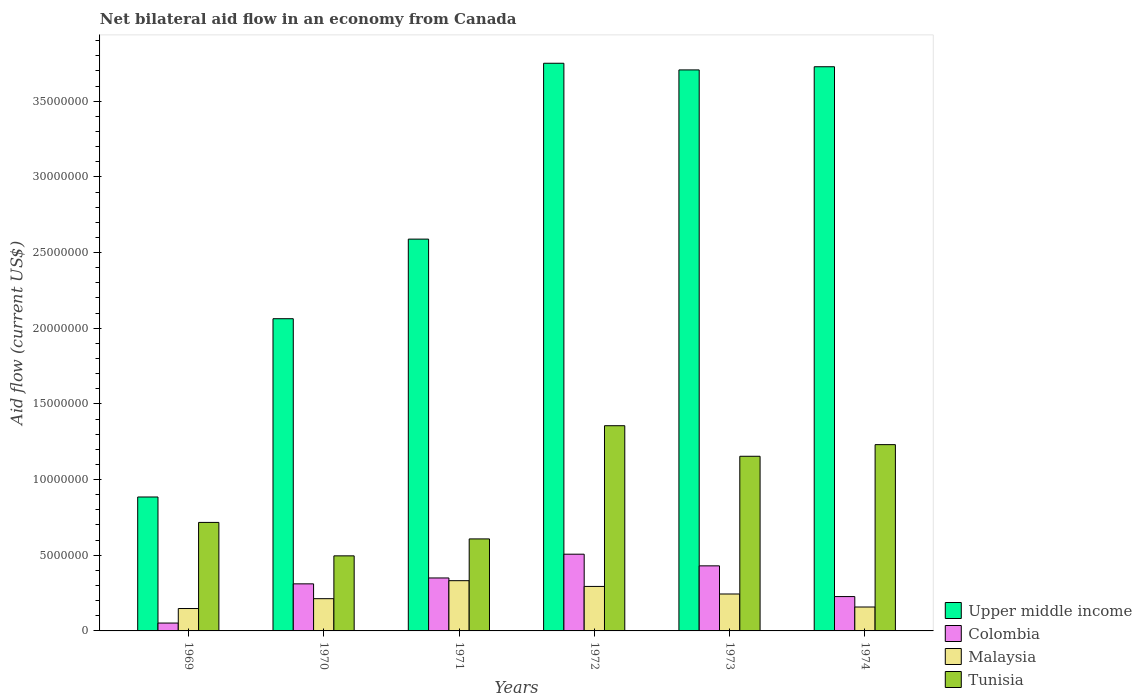Are the number of bars on each tick of the X-axis equal?
Keep it short and to the point. Yes. How many bars are there on the 2nd tick from the left?
Make the answer very short. 4. How many bars are there on the 6th tick from the right?
Keep it short and to the point. 4. What is the label of the 5th group of bars from the left?
Ensure brevity in your answer.  1973. In how many cases, is the number of bars for a given year not equal to the number of legend labels?
Make the answer very short. 0. What is the net bilateral aid flow in Tunisia in 1971?
Your answer should be compact. 6.08e+06. Across all years, what is the maximum net bilateral aid flow in Colombia?
Your answer should be very brief. 5.07e+06. Across all years, what is the minimum net bilateral aid flow in Upper middle income?
Provide a succinct answer. 8.85e+06. In which year was the net bilateral aid flow in Colombia minimum?
Keep it short and to the point. 1969. What is the total net bilateral aid flow in Colombia in the graph?
Give a very brief answer. 1.88e+07. What is the difference between the net bilateral aid flow in Tunisia in 1971 and that in 1972?
Provide a succinct answer. -7.48e+06. What is the difference between the net bilateral aid flow in Upper middle income in 1969 and the net bilateral aid flow in Malaysia in 1971?
Keep it short and to the point. 5.53e+06. What is the average net bilateral aid flow in Malaysia per year?
Make the answer very short. 2.32e+06. In the year 1969, what is the difference between the net bilateral aid flow in Upper middle income and net bilateral aid flow in Colombia?
Offer a terse response. 8.33e+06. What is the ratio of the net bilateral aid flow in Upper middle income in 1969 to that in 1973?
Offer a terse response. 0.24. Is the net bilateral aid flow in Tunisia in 1972 less than that in 1973?
Offer a very short reply. No. Is the difference between the net bilateral aid flow in Upper middle income in 1972 and 1974 greater than the difference between the net bilateral aid flow in Colombia in 1972 and 1974?
Offer a terse response. No. What is the difference between the highest and the lowest net bilateral aid flow in Colombia?
Your answer should be very brief. 4.55e+06. In how many years, is the net bilateral aid flow in Colombia greater than the average net bilateral aid flow in Colombia taken over all years?
Provide a succinct answer. 3. Is the sum of the net bilateral aid flow in Upper middle income in 1973 and 1974 greater than the maximum net bilateral aid flow in Malaysia across all years?
Keep it short and to the point. Yes. Is it the case that in every year, the sum of the net bilateral aid flow in Upper middle income and net bilateral aid flow in Malaysia is greater than the sum of net bilateral aid flow in Tunisia and net bilateral aid flow in Colombia?
Offer a very short reply. Yes. What does the 3rd bar from the left in 1969 represents?
Offer a very short reply. Malaysia. What does the 2nd bar from the right in 1973 represents?
Provide a succinct answer. Malaysia. Is it the case that in every year, the sum of the net bilateral aid flow in Malaysia and net bilateral aid flow in Colombia is greater than the net bilateral aid flow in Tunisia?
Make the answer very short. No. How many bars are there?
Provide a succinct answer. 24. Are all the bars in the graph horizontal?
Keep it short and to the point. No. What is the difference between two consecutive major ticks on the Y-axis?
Provide a short and direct response. 5.00e+06. How are the legend labels stacked?
Ensure brevity in your answer.  Vertical. What is the title of the graph?
Offer a terse response. Net bilateral aid flow in an economy from Canada. Does "Myanmar" appear as one of the legend labels in the graph?
Offer a very short reply. No. What is the Aid flow (current US$) of Upper middle income in 1969?
Ensure brevity in your answer.  8.85e+06. What is the Aid flow (current US$) in Colombia in 1969?
Your answer should be compact. 5.20e+05. What is the Aid flow (current US$) of Malaysia in 1969?
Offer a very short reply. 1.48e+06. What is the Aid flow (current US$) of Tunisia in 1969?
Give a very brief answer. 7.17e+06. What is the Aid flow (current US$) in Upper middle income in 1970?
Provide a succinct answer. 2.06e+07. What is the Aid flow (current US$) of Colombia in 1970?
Offer a very short reply. 3.11e+06. What is the Aid flow (current US$) in Malaysia in 1970?
Provide a short and direct response. 2.13e+06. What is the Aid flow (current US$) in Tunisia in 1970?
Provide a succinct answer. 4.96e+06. What is the Aid flow (current US$) in Upper middle income in 1971?
Provide a short and direct response. 2.59e+07. What is the Aid flow (current US$) in Colombia in 1971?
Offer a terse response. 3.50e+06. What is the Aid flow (current US$) of Malaysia in 1971?
Offer a very short reply. 3.32e+06. What is the Aid flow (current US$) of Tunisia in 1971?
Provide a short and direct response. 6.08e+06. What is the Aid flow (current US$) in Upper middle income in 1972?
Your answer should be very brief. 3.75e+07. What is the Aid flow (current US$) of Colombia in 1972?
Your answer should be very brief. 5.07e+06. What is the Aid flow (current US$) in Malaysia in 1972?
Keep it short and to the point. 2.94e+06. What is the Aid flow (current US$) in Tunisia in 1972?
Offer a terse response. 1.36e+07. What is the Aid flow (current US$) in Upper middle income in 1973?
Give a very brief answer. 3.71e+07. What is the Aid flow (current US$) of Colombia in 1973?
Provide a succinct answer. 4.30e+06. What is the Aid flow (current US$) of Malaysia in 1973?
Offer a very short reply. 2.44e+06. What is the Aid flow (current US$) in Tunisia in 1973?
Provide a short and direct response. 1.15e+07. What is the Aid flow (current US$) of Upper middle income in 1974?
Your answer should be very brief. 3.73e+07. What is the Aid flow (current US$) of Colombia in 1974?
Provide a short and direct response. 2.27e+06. What is the Aid flow (current US$) of Malaysia in 1974?
Provide a short and direct response. 1.58e+06. What is the Aid flow (current US$) of Tunisia in 1974?
Provide a succinct answer. 1.23e+07. Across all years, what is the maximum Aid flow (current US$) in Upper middle income?
Your answer should be very brief. 3.75e+07. Across all years, what is the maximum Aid flow (current US$) in Colombia?
Ensure brevity in your answer.  5.07e+06. Across all years, what is the maximum Aid flow (current US$) in Malaysia?
Give a very brief answer. 3.32e+06. Across all years, what is the maximum Aid flow (current US$) in Tunisia?
Your answer should be compact. 1.36e+07. Across all years, what is the minimum Aid flow (current US$) in Upper middle income?
Your answer should be very brief. 8.85e+06. Across all years, what is the minimum Aid flow (current US$) in Colombia?
Provide a succinct answer. 5.20e+05. Across all years, what is the minimum Aid flow (current US$) of Malaysia?
Make the answer very short. 1.48e+06. Across all years, what is the minimum Aid flow (current US$) in Tunisia?
Ensure brevity in your answer.  4.96e+06. What is the total Aid flow (current US$) of Upper middle income in the graph?
Make the answer very short. 1.67e+08. What is the total Aid flow (current US$) of Colombia in the graph?
Offer a very short reply. 1.88e+07. What is the total Aid flow (current US$) of Malaysia in the graph?
Give a very brief answer. 1.39e+07. What is the total Aid flow (current US$) of Tunisia in the graph?
Your answer should be compact. 5.56e+07. What is the difference between the Aid flow (current US$) of Upper middle income in 1969 and that in 1970?
Keep it short and to the point. -1.18e+07. What is the difference between the Aid flow (current US$) of Colombia in 1969 and that in 1970?
Your answer should be very brief. -2.59e+06. What is the difference between the Aid flow (current US$) in Malaysia in 1969 and that in 1970?
Offer a very short reply. -6.50e+05. What is the difference between the Aid flow (current US$) of Tunisia in 1969 and that in 1970?
Keep it short and to the point. 2.21e+06. What is the difference between the Aid flow (current US$) in Upper middle income in 1969 and that in 1971?
Offer a terse response. -1.70e+07. What is the difference between the Aid flow (current US$) in Colombia in 1969 and that in 1971?
Your response must be concise. -2.98e+06. What is the difference between the Aid flow (current US$) of Malaysia in 1969 and that in 1971?
Your response must be concise. -1.84e+06. What is the difference between the Aid flow (current US$) in Tunisia in 1969 and that in 1971?
Give a very brief answer. 1.09e+06. What is the difference between the Aid flow (current US$) in Upper middle income in 1969 and that in 1972?
Offer a terse response. -2.87e+07. What is the difference between the Aid flow (current US$) of Colombia in 1969 and that in 1972?
Offer a very short reply. -4.55e+06. What is the difference between the Aid flow (current US$) in Malaysia in 1969 and that in 1972?
Provide a succinct answer. -1.46e+06. What is the difference between the Aid flow (current US$) in Tunisia in 1969 and that in 1972?
Ensure brevity in your answer.  -6.39e+06. What is the difference between the Aid flow (current US$) in Upper middle income in 1969 and that in 1973?
Ensure brevity in your answer.  -2.82e+07. What is the difference between the Aid flow (current US$) of Colombia in 1969 and that in 1973?
Keep it short and to the point. -3.78e+06. What is the difference between the Aid flow (current US$) of Malaysia in 1969 and that in 1973?
Your answer should be compact. -9.60e+05. What is the difference between the Aid flow (current US$) of Tunisia in 1969 and that in 1973?
Your response must be concise. -4.37e+06. What is the difference between the Aid flow (current US$) in Upper middle income in 1969 and that in 1974?
Ensure brevity in your answer.  -2.84e+07. What is the difference between the Aid flow (current US$) in Colombia in 1969 and that in 1974?
Make the answer very short. -1.75e+06. What is the difference between the Aid flow (current US$) in Tunisia in 1969 and that in 1974?
Offer a very short reply. -5.14e+06. What is the difference between the Aid flow (current US$) of Upper middle income in 1970 and that in 1971?
Offer a very short reply. -5.26e+06. What is the difference between the Aid flow (current US$) in Colombia in 1970 and that in 1971?
Your answer should be very brief. -3.90e+05. What is the difference between the Aid flow (current US$) of Malaysia in 1970 and that in 1971?
Provide a succinct answer. -1.19e+06. What is the difference between the Aid flow (current US$) in Tunisia in 1970 and that in 1971?
Provide a succinct answer. -1.12e+06. What is the difference between the Aid flow (current US$) in Upper middle income in 1970 and that in 1972?
Provide a succinct answer. -1.69e+07. What is the difference between the Aid flow (current US$) of Colombia in 1970 and that in 1972?
Provide a succinct answer. -1.96e+06. What is the difference between the Aid flow (current US$) of Malaysia in 1970 and that in 1972?
Your answer should be very brief. -8.10e+05. What is the difference between the Aid flow (current US$) of Tunisia in 1970 and that in 1972?
Offer a terse response. -8.60e+06. What is the difference between the Aid flow (current US$) of Upper middle income in 1970 and that in 1973?
Keep it short and to the point. -1.64e+07. What is the difference between the Aid flow (current US$) of Colombia in 1970 and that in 1973?
Offer a very short reply. -1.19e+06. What is the difference between the Aid flow (current US$) in Malaysia in 1970 and that in 1973?
Keep it short and to the point. -3.10e+05. What is the difference between the Aid flow (current US$) in Tunisia in 1970 and that in 1973?
Make the answer very short. -6.58e+06. What is the difference between the Aid flow (current US$) in Upper middle income in 1970 and that in 1974?
Your answer should be very brief. -1.66e+07. What is the difference between the Aid flow (current US$) of Colombia in 1970 and that in 1974?
Your answer should be compact. 8.40e+05. What is the difference between the Aid flow (current US$) of Tunisia in 1970 and that in 1974?
Offer a very short reply. -7.35e+06. What is the difference between the Aid flow (current US$) in Upper middle income in 1971 and that in 1972?
Your answer should be compact. -1.16e+07. What is the difference between the Aid flow (current US$) of Colombia in 1971 and that in 1972?
Your answer should be very brief. -1.57e+06. What is the difference between the Aid flow (current US$) of Malaysia in 1971 and that in 1972?
Offer a terse response. 3.80e+05. What is the difference between the Aid flow (current US$) of Tunisia in 1971 and that in 1972?
Ensure brevity in your answer.  -7.48e+06. What is the difference between the Aid flow (current US$) in Upper middle income in 1971 and that in 1973?
Your answer should be compact. -1.12e+07. What is the difference between the Aid flow (current US$) in Colombia in 1971 and that in 1973?
Offer a terse response. -8.00e+05. What is the difference between the Aid flow (current US$) of Malaysia in 1971 and that in 1973?
Offer a very short reply. 8.80e+05. What is the difference between the Aid flow (current US$) in Tunisia in 1971 and that in 1973?
Give a very brief answer. -5.46e+06. What is the difference between the Aid flow (current US$) in Upper middle income in 1971 and that in 1974?
Your answer should be very brief. -1.14e+07. What is the difference between the Aid flow (current US$) in Colombia in 1971 and that in 1974?
Ensure brevity in your answer.  1.23e+06. What is the difference between the Aid flow (current US$) in Malaysia in 1971 and that in 1974?
Your answer should be very brief. 1.74e+06. What is the difference between the Aid flow (current US$) in Tunisia in 1971 and that in 1974?
Your answer should be very brief. -6.23e+06. What is the difference between the Aid flow (current US$) of Colombia in 1972 and that in 1973?
Keep it short and to the point. 7.70e+05. What is the difference between the Aid flow (current US$) in Malaysia in 1972 and that in 1973?
Provide a succinct answer. 5.00e+05. What is the difference between the Aid flow (current US$) in Tunisia in 1972 and that in 1973?
Your answer should be compact. 2.02e+06. What is the difference between the Aid flow (current US$) in Upper middle income in 1972 and that in 1974?
Make the answer very short. 2.30e+05. What is the difference between the Aid flow (current US$) of Colombia in 1972 and that in 1974?
Offer a very short reply. 2.80e+06. What is the difference between the Aid flow (current US$) in Malaysia in 1972 and that in 1974?
Your answer should be very brief. 1.36e+06. What is the difference between the Aid flow (current US$) of Tunisia in 1972 and that in 1974?
Provide a short and direct response. 1.25e+06. What is the difference between the Aid flow (current US$) of Upper middle income in 1973 and that in 1974?
Provide a short and direct response. -2.10e+05. What is the difference between the Aid flow (current US$) of Colombia in 1973 and that in 1974?
Keep it short and to the point. 2.03e+06. What is the difference between the Aid flow (current US$) of Malaysia in 1973 and that in 1974?
Ensure brevity in your answer.  8.60e+05. What is the difference between the Aid flow (current US$) of Tunisia in 1973 and that in 1974?
Ensure brevity in your answer.  -7.70e+05. What is the difference between the Aid flow (current US$) of Upper middle income in 1969 and the Aid flow (current US$) of Colombia in 1970?
Offer a very short reply. 5.74e+06. What is the difference between the Aid flow (current US$) in Upper middle income in 1969 and the Aid flow (current US$) in Malaysia in 1970?
Make the answer very short. 6.72e+06. What is the difference between the Aid flow (current US$) of Upper middle income in 1969 and the Aid flow (current US$) of Tunisia in 1970?
Make the answer very short. 3.89e+06. What is the difference between the Aid flow (current US$) of Colombia in 1969 and the Aid flow (current US$) of Malaysia in 1970?
Your response must be concise. -1.61e+06. What is the difference between the Aid flow (current US$) of Colombia in 1969 and the Aid flow (current US$) of Tunisia in 1970?
Offer a terse response. -4.44e+06. What is the difference between the Aid flow (current US$) in Malaysia in 1969 and the Aid flow (current US$) in Tunisia in 1970?
Offer a very short reply. -3.48e+06. What is the difference between the Aid flow (current US$) in Upper middle income in 1969 and the Aid flow (current US$) in Colombia in 1971?
Make the answer very short. 5.35e+06. What is the difference between the Aid flow (current US$) in Upper middle income in 1969 and the Aid flow (current US$) in Malaysia in 1971?
Keep it short and to the point. 5.53e+06. What is the difference between the Aid flow (current US$) in Upper middle income in 1969 and the Aid flow (current US$) in Tunisia in 1971?
Provide a succinct answer. 2.77e+06. What is the difference between the Aid flow (current US$) in Colombia in 1969 and the Aid flow (current US$) in Malaysia in 1971?
Your answer should be very brief. -2.80e+06. What is the difference between the Aid flow (current US$) in Colombia in 1969 and the Aid flow (current US$) in Tunisia in 1971?
Provide a short and direct response. -5.56e+06. What is the difference between the Aid flow (current US$) in Malaysia in 1969 and the Aid flow (current US$) in Tunisia in 1971?
Provide a succinct answer. -4.60e+06. What is the difference between the Aid flow (current US$) of Upper middle income in 1969 and the Aid flow (current US$) of Colombia in 1972?
Make the answer very short. 3.78e+06. What is the difference between the Aid flow (current US$) in Upper middle income in 1969 and the Aid flow (current US$) in Malaysia in 1972?
Keep it short and to the point. 5.91e+06. What is the difference between the Aid flow (current US$) in Upper middle income in 1969 and the Aid flow (current US$) in Tunisia in 1972?
Make the answer very short. -4.71e+06. What is the difference between the Aid flow (current US$) of Colombia in 1969 and the Aid flow (current US$) of Malaysia in 1972?
Offer a terse response. -2.42e+06. What is the difference between the Aid flow (current US$) in Colombia in 1969 and the Aid flow (current US$) in Tunisia in 1972?
Your response must be concise. -1.30e+07. What is the difference between the Aid flow (current US$) of Malaysia in 1969 and the Aid flow (current US$) of Tunisia in 1972?
Provide a succinct answer. -1.21e+07. What is the difference between the Aid flow (current US$) of Upper middle income in 1969 and the Aid flow (current US$) of Colombia in 1973?
Ensure brevity in your answer.  4.55e+06. What is the difference between the Aid flow (current US$) in Upper middle income in 1969 and the Aid flow (current US$) in Malaysia in 1973?
Offer a very short reply. 6.41e+06. What is the difference between the Aid flow (current US$) of Upper middle income in 1969 and the Aid flow (current US$) of Tunisia in 1973?
Offer a very short reply. -2.69e+06. What is the difference between the Aid flow (current US$) in Colombia in 1969 and the Aid flow (current US$) in Malaysia in 1973?
Offer a terse response. -1.92e+06. What is the difference between the Aid flow (current US$) of Colombia in 1969 and the Aid flow (current US$) of Tunisia in 1973?
Provide a short and direct response. -1.10e+07. What is the difference between the Aid flow (current US$) of Malaysia in 1969 and the Aid flow (current US$) of Tunisia in 1973?
Your answer should be very brief. -1.01e+07. What is the difference between the Aid flow (current US$) in Upper middle income in 1969 and the Aid flow (current US$) in Colombia in 1974?
Your response must be concise. 6.58e+06. What is the difference between the Aid flow (current US$) of Upper middle income in 1969 and the Aid flow (current US$) of Malaysia in 1974?
Your answer should be compact. 7.27e+06. What is the difference between the Aid flow (current US$) of Upper middle income in 1969 and the Aid flow (current US$) of Tunisia in 1974?
Provide a succinct answer. -3.46e+06. What is the difference between the Aid flow (current US$) of Colombia in 1969 and the Aid flow (current US$) of Malaysia in 1974?
Ensure brevity in your answer.  -1.06e+06. What is the difference between the Aid flow (current US$) of Colombia in 1969 and the Aid flow (current US$) of Tunisia in 1974?
Offer a very short reply. -1.18e+07. What is the difference between the Aid flow (current US$) in Malaysia in 1969 and the Aid flow (current US$) in Tunisia in 1974?
Offer a terse response. -1.08e+07. What is the difference between the Aid flow (current US$) in Upper middle income in 1970 and the Aid flow (current US$) in Colombia in 1971?
Ensure brevity in your answer.  1.71e+07. What is the difference between the Aid flow (current US$) in Upper middle income in 1970 and the Aid flow (current US$) in Malaysia in 1971?
Offer a very short reply. 1.73e+07. What is the difference between the Aid flow (current US$) of Upper middle income in 1970 and the Aid flow (current US$) of Tunisia in 1971?
Make the answer very short. 1.46e+07. What is the difference between the Aid flow (current US$) in Colombia in 1970 and the Aid flow (current US$) in Malaysia in 1971?
Your answer should be compact. -2.10e+05. What is the difference between the Aid flow (current US$) of Colombia in 1970 and the Aid flow (current US$) of Tunisia in 1971?
Offer a very short reply. -2.97e+06. What is the difference between the Aid flow (current US$) in Malaysia in 1970 and the Aid flow (current US$) in Tunisia in 1971?
Give a very brief answer. -3.95e+06. What is the difference between the Aid flow (current US$) of Upper middle income in 1970 and the Aid flow (current US$) of Colombia in 1972?
Make the answer very short. 1.56e+07. What is the difference between the Aid flow (current US$) in Upper middle income in 1970 and the Aid flow (current US$) in Malaysia in 1972?
Ensure brevity in your answer.  1.77e+07. What is the difference between the Aid flow (current US$) in Upper middle income in 1970 and the Aid flow (current US$) in Tunisia in 1972?
Offer a terse response. 7.07e+06. What is the difference between the Aid flow (current US$) of Colombia in 1970 and the Aid flow (current US$) of Tunisia in 1972?
Your answer should be compact. -1.04e+07. What is the difference between the Aid flow (current US$) of Malaysia in 1970 and the Aid flow (current US$) of Tunisia in 1972?
Offer a very short reply. -1.14e+07. What is the difference between the Aid flow (current US$) of Upper middle income in 1970 and the Aid flow (current US$) of Colombia in 1973?
Offer a terse response. 1.63e+07. What is the difference between the Aid flow (current US$) of Upper middle income in 1970 and the Aid flow (current US$) of Malaysia in 1973?
Your answer should be very brief. 1.82e+07. What is the difference between the Aid flow (current US$) in Upper middle income in 1970 and the Aid flow (current US$) in Tunisia in 1973?
Your response must be concise. 9.09e+06. What is the difference between the Aid flow (current US$) in Colombia in 1970 and the Aid flow (current US$) in Malaysia in 1973?
Make the answer very short. 6.70e+05. What is the difference between the Aid flow (current US$) in Colombia in 1970 and the Aid flow (current US$) in Tunisia in 1973?
Keep it short and to the point. -8.43e+06. What is the difference between the Aid flow (current US$) in Malaysia in 1970 and the Aid flow (current US$) in Tunisia in 1973?
Give a very brief answer. -9.41e+06. What is the difference between the Aid flow (current US$) in Upper middle income in 1970 and the Aid flow (current US$) in Colombia in 1974?
Give a very brief answer. 1.84e+07. What is the difference between the Aid flow (current US$) of Upper middle income in 1970 and the Aid flow (current US$) of Malaysia in 1974?
Offer a very short reply. 1.90e+07. What is the difference between the Aid flow (current US$) of Upper middle income in 1970 and the Aid flow (current US$) of Tunisia in 1974?
Ensure brevity in your answer.  8.32e+06. What is the difference between the Aid flow (current US$) of Colombia in 1970 and the Aid flow (current US$) of Malaysia in 1974?
Offer a very short reply. 1.53e+06. What is the difference between the Aid flow (current US$) of Colombia in 1970 and the Aid flow (current US$) of Tunisia in 1974?
Your response must be concise. -9.20e+06. What is the difference between the Aid flow (current US$) in Malaysia in 1970 and the Aid flow (current US$) in Tunisia in 1974?
Provide a succinct answer. -1.02e+07. What is the difference between the Aid flow (current US$) in Upper middle income in 1971 and the Aid flow (current US$) in Colombia in 1972?
Ensure brevity in your answer.  2.08e+07. What is the difference between the Aid flow (current US$) in Upper middle income in 1971 and the Aid flow (current US$) in Malaysia in 1972?
Offer a terse response. 2.30e+07. What is the difference between the Aid flow (current US$) of Upper middle income in 1971 and the Aid flow (current US$) of Tunisia in 1972?
Give a very brief answer. 1.23e+07. What is the difference between the Aid flow (current US$) of Colombia in 1971 and the Aid flow (current US$) of Malaysia in 1972?
Provide a short and direct response. 5.60e+05. What is the difference between the Aid flow (current US$) in Colombia in 1971 and the Aid flow (current US$) in Tunisia in 1972?
Ensure brevity in your answer.  -1.01e+07. What is the difference between the Aid flow (current US$) in Malaysia in 1971 and the Aid flow (current US$) in Tunisia in 1972?
Keep it short and to the point. -1.02e+07. What is the difference between the Aid flow (current US$) of Upper middle income in 1971 and the Aid flow (current US$) of Colombia in 1973?
Keep it short and to the point. 2.16e+07. What is the difference between the Aid flow (current US$) of Upper middle income in 1971 and the Aid flow (current US$) of Malaysia in 1973?
Keep it short and to the point. 2.34e+07. What is the difference between the Aid flow (current US$) of Upper middle income in 1971 and the Aid flow (current US$) of Tunisia in 1973?
Give a very brief answer. 1.44e+07. What is the difference between the Aid flow (current US$) in Colombia in 1971 and the Aid flow (current US$) in Malaysia in 1973?
Make the answer very short. 1.06e+06. What is the difference between the Aid flow (current US$) of Colombia in 1971 and the Aid flow (current US$) of Tunisia in 1973?
Keep it short and to the point. -8.04e+06. What is the difference between the Aid flow (current US$) of Malaysia in 1971 and the Aid flow (current US$) of Tunisia in 1973?
Provide a succinct answer. -8.22e+06. What is the difference between the Aid flow (current US$) in Upper middle income in 1971 and the Aid flow (current US$) in Colombia in 1974?
Give a very brief answer. 2.36e+07. What is the difference between the Aid flow (current US$) of Upper middle income in 1971 and the Aid flow (current US$) of Malaysia in 1974?
Offer a terse response. 2.43e+07. What is the difference between the Aid flow (current US$) in Upper middle income in 1971 and the Aid flow (current US$) in Tunisia in 1974?
Offer a terse response. 1.36e+07. What is the difference between the Aid flow (current US$) in Colombia in 1971 and the Aid flow (current US$) in Malaysia in 1974?
Give a very brief answer. 1.92e+06. What is the difference between the Aid flow (current US$) in Colombia in 1971 and the Aid flow (current US$) in Tunisia in 1974?
Provide a succinct answer. -8.81e+06. What is the difference between the Aid flow (current US$) of Malaysia in 1971 and the Aid flow (current US$) of Tunisia in 1974?
Provide a succinct answer. -8.99e+06. What is the difference between the Aid flow (current US$) of Upper middle income in 1972 and the Aid flow (current US$) of Colombia in 1973?
Your answer should be compact. 3.32e+07. What is the difference between the Aid flow (current US$) of Upper middle income in 1972 and the Aid flow (current US$) of Malaysia in 1973?
Your response must be concise. 3.51e+07. What is the difference between the Aid flow (current US$) in Upper middle income in 1972 and the Aid flow (current US$) in Tunisia in 1973?
Your response must be concise. 2.60e+07. What is the difference between the Aid flow (current US$) of Colombia in 1972 and the Aid flow (current US$) of Malaysia in 1973?
Ensure brevity in your answer.  2.63e+06. What is the difference between the Aid flow (current US$) of Colombia in 1972 and the Aid flow (current US$) of Tunisia in 1973?
Your response must be concise. -6.47e+06. What is the difference between the Aid flow (current US$) in Malaysia in 1972 and the Aid flow (current US$) in Tunisia in 1973?
Your answer should be compact. -8.60e+06. What is the difference between the Aid flow (current US$) in Upper middle income in 1972 and the Aid flow (current US$) in Colombia in 1974?
Ensure brevity in your answer.  3.52e+07. What is the difference between the Aid flow (current US$) of Upper middle income in 1972 and the Aid flow (current US$) of Malaysia in 1974?
Your answer should be very brief. 3.59e+07. What is the difference between the Aid flow (current US$) in Upper middle income in 1972 and the Aid flow (current US$) in Tunisia in 1974?
Your response must be concise. 2.52e+07. What is the difference between the Aid flow (current US$) of Colombia in 1972 and the Aid flow (current US$) of Malaysia in 1974?
Provide a succinct answer. 3.49e+06. What is the difference between the Aid flow (current US$) of Colombia in 1972 and the Aid flow (current US$) of Tunisia in 1974?
Your answer should be very brief. -7.24e+06. What is the difference between the Aid flow (current US$) in Malaysia in 1972 and the Aid flow (current US$) in Tunisia in 1974?
Keep it short and to the point. -9.37e+06. What is the difference between the Aid flow (current US$) of Upper middle income in 1973 and the Aid flow (current US$) of Colombia in 1974?
Keep it short and to the point. 3.48e+07. What is the difference between the Aid flow (current US$) in Upper middle income in 1973 and the Aid flow (current US$) in Malaysia in 1974?
Your answer should be compact. 3.55e+07. What is the difference between the Aid flow (current US$) in Upper middle income in 1973 and the Aid flow (current US$) in Tunisia in 1974?
Your response must be concise. 2.48e+07. What is the difference between the Aid flow (current US$) of Colombia in 1973 and the Aid flow (current US$) of Malaysia in 1974?
Make the answer very short. 2.72e+06. What is the difference between the Aid flow (current US$) in Colombia in 1973 and the Aid flow (current US$) in Tunisia in 1974?
Your response must be concise. -8.01e+06. What is the difference between the Aid flow (current US$) in Malaysia in 1973 and the Aid flow (current US$) in Tunisia in 1974?
Make the answer very short. -9.87e+06. What is the average Aid flow (current US$) in Upper middle income per year?
Your answer should be compact. 2.79e+07. What is the average Aid flow (current US$) of Colombia per year?
Make the answer very short. 3.13e+06. What is the average Aid flow (current US$) of Malaysia per year?
Your response must be concise. 2.32e+06. What is the average Aid flow (current US$) of Tunisia per year?
Your answer should be compact. 9.27e+06. In the year 1969, what is the difference between the Aid flow (current US$) of Upper middle income and Aid flow (current US$) of Colombia?
Give a very brief answer. 8.33e+06. In the year 1969, what is the difference between the Aid flow (current US$) of Upper middle income and Aid flow (current US$) of Malaysia?
Give a very brief answer. 7.37e+06. In the year 1969, what is the difference between the Aid flow (current US$) in Upper middle income and Aid flow (current US$) in Tunisia?
Your answer should be very brief. 1.68e+06. In the year 1969, what is the difference between the Aid flow (current US$) in Colombia and Aid flow (current US$) in Malaysia?
Make the answer very short. -9.60e+05. In the year 1969, what is the difference between the Aid flow (current US$) in Colombia and Aid flow (current US$) in Tunisia?
Your answer should be compact. -6.65e+06. In the year 1969, what is the difference between the Aid flow (current US$) in Malaysia and Aid flow (current US$) in Tunisia?
Provide a short and direct response. -5.69e+06. In the year 1970, what is the difference between the Aid flow (current US$) in Upper middle income and Aid flow (current US$) in Colombia?
Offer a very short reply. 1.75e+07. In the year 1970, what is the difference between the Aid flow (current US$) of Upper middle income and Aid flow (current US$) of Malaysia?
Offer a terse response. 1.85e+07. In the year 1970, what is the difference between the Aid flow (current US$) in Upper middle income and Aid flow (current US$) in Tunisia?
Offer a terse response. 1.57e+07. In the year 1970, what is the difference between the Aid flow (current US$) of Colombia and Aid flow (current US$) of Malaysia?
Your answer should be very brief. 9.80e+05. In the year 1970, what is the difference between the Aid flow (current US$) in Colombia and Aid flow (current US$) in Tunisia?
Your answer should be compact. -1.85e+06. In the year 1970, what is the difference between the Aid flow (current US$) in Malaysia and Aid flow (current US$) in Tunisia?
Offer a very short reply. -2.83e+06. In the year 1971, what is the difference between the Aid flow (current US$) of Upper middle income and Aid flow (current US$) of Colombia?
Make the answer very short. 2.24e+07. In the year 1971, what is the difference between the Aid flow (current US$) of Upper middle income and Aid flow (current US$) of Malaysia?
Make the answer very short. 2.26e+07. In the year 1971, what is the difference between the Aid flow (current US$) of Upper middle income and Aid flow (current US$) of Tunisia?
Your answer should be compact. 1.98e+07. In the year 1971, what is the difference between the Aid flow (current US$) in Colombia and Aid flow (current US$) in Malaysia?
Provide a succinct answer. 1.80e+05. In the year 1971, what is the difference between the Aid flow (current US$) of Colombia and Aid flow (current US$) of Tunisia?
Offer a very short reply. -2.58e+06. In the year 1971, what is the difference between the Aid flow (current US$) in Malaysia and Aid flow (current US$) in Tunisia?
Provide a succinct answer. -2.76e+06. In the year 1972, what is the difference between the Aid flow (current US$) in Upper middle income and Aid flow (current US$) in Colombia?
Offer a terse response. 3.24e+07. In the year 1972, what is the difference between the Aid flow (current US$) in Upper middle income and Aid flow (current US$) in Malaysia?
Offer a terse response. 3.46e+07. In the year 1972, what is the difference between the Aid flow (current US$) in Upper middle income and Aid flow (current US$) in Tunisia?
Ensure brevity in your answer.  2.40e+07. In the year 1972, what is the difference between the Aid flow (current US$) in Colombia and Aid flow (current US$) in Malaysia?
Give a very brief answer. 2.13e+06. In the year 1972, what is the difference between the Aid flow (current US$) of Colombia and Aid flow (current US$) of Tunisia?
Ensure brevity in your answer.  -8.49e+06. In the year 1972, what is the difference between the Aid flow (current US$) in Malaysia and Aid flow (current US$) in Tunisia?
Offer a terse response. -1.06e+07. In the year 1973, what is the difference between the Aid flow (current US$) in Upper middle income and Aid flow (current US$) in Colombia?
Give a very brief answer. 3.28e+07. In the year 1973, what is the difference between the Aid flow (current US$) of Upper middle income and Aid flow (current US$) of Malaysia?
Your response must be concise. 3.46e+07. In the year 1973, what is the difference between the Aid flow (current US$) in Upper middle income and Aid flow (current US$) in Tunisia?
Your answer should be very brief. 2.55e+07. In the year 1973, what is the difference between the Aid flow (current US$) of Colombia and Aid flow (current US$) of Malaysia?
Your answer should be very brief. 1.86e+06. In the year 1973, what is the difference between the Aid flow (current US$) in Colombia and Aid flow (current US$) in Tunisia?
Offer a very short reply. -7.24e+06. In the year 1973, what is the difference between the Aid flow (current US$) of Malaysia and Aid flow (current US$) of Tunisia?
Offer a very short reply. -9.10e+06. In the year 1974, what is the difference between the Aid flow (current US$) in Upper middle income and Aid flow (current US$) in Colombia?
Provide a short and direct response. 3.50e+07. In the year 1974, what is the difference between the Aid flow (current US$) of Upper middle income and Aid flow (current US$) of Malaysia?
Make the answer very short. 3.57e+07. In the year 1974, what is the difference between the Aid flow (current US$) of Upper middle income and Aid flow (current US$) of Tunisia?
Provide a succinct answer. 2.50e+07. In the year 1974, what is the difference between the Aid flow (current US$) in Colombia and Aid flow (current US$) in Malaysia?
Keep it short and to the point. 6.90e+05. In the year 1974, what is the difference between the Aid flow (current US$) of Colombia and Aid flow (current US$) of Tunisia?
Offer a very short reply. -1.00e+07. In the year 1974, what is the difference between the Aid flow (current US$) in Malaysia and Aid flow (current US$) in Tunisia?
Keep it short and to the point. -1.07e+07. What is the ratio of the Aid flow (current US$) in Upper middle income in 1969 to that in 1970?
Ensure brevity in your answer.  0.43. What is the ratio of the Aid flow (current US$) of Colombia in 1969 to that in 1970?
Provide a succinct answer. 0.17. What is the ratio of the Aid flow (current US$) in Malaysia in 1969 to that in 1970?
Offer a very short reply. 0.69. What is the ratio of the Aid flow (current US$) in Tunisia in 1969 to that in 1970?
Ensure brevity in your answer.  1.45. What is the ratio of the Aid flow (current US$) in Upper middle income in 1969 to that in 1971?
Your response must be concise. 0.34. What is the ratio of the Aid flow (current US$) in Colombia in 1969 to that in 1971?
Offer a very short reply. 0.15. What is the ratio of the Aid flow (current US$) in Malaysia in 1969 to that in 1971?
Keep it short and to the point. 0.45. What is the ratio of the Aid flow (current US$) in Tunisia in 1969 to that in 1971?
Ensure brevity in your answer.  1.18. What is the ratio of the Aid flow (current US$) of Upper middle income in 1969 to that in 1972?
Give a very brief answer. 0.24. What is the ratio of the Aid flow (current US$) of Colombia in 1969 to that in 1972?
Give a very brief answer. 0.1. What is the ratio of the Aid flow (current US$) in Malaysia in 1969 to that in 1972?
Ensure brevity in your answer.  0.5. What is the ratio of the Aid flow (current US$) of Tunisia in 1969 to that in 1972?
Your answer should be compact. 0.53. What is the ratio of the Aid flow (current US$) of Upper middle income in 1969 to that in 1973?
Offer a very short reply. 0.24. What is the ratio of the Aid flow (current US$) of Colombia in 1969 to that in 1973?
Give a very brief answer. 0.12. What is the ratio of the Aid flow (current US$) of Malaysia in 1969 to that in 1973?
Offer a very short reply. 0.61. What is the ratio of the Aid flow (current US$) in Tunisia in 1969 to that in 1973?
Provide a succinct answer. 0.62. What is the ratio of the Aid flow (current US$) in Upper middle income in 1969 to that in 1974?
Give a very brief answer. 0.24. What is the ratio of the Aid flow (current US$) of Colombia in 1969 to that in 1974?
Provide a short and direct response. 0.23. What is the ratio of the Aid flow (current US$) in Malaysia in 1969 to that in 1974?
Make the answer very short. 0.94. What is the ratio of the Aid flow (current US$) in Tunisia in 1969 to that in 1974?
Keep it short and to the point. 0.58. What is the ratio of the Aid flow (current US$) in Upper middle income in 1970 to that in 1971?
Offer a terse response. 0.8. What is the ratio of the Aid flow (current US$) in Colombia in 1970 to that in 1971?
Your response must be concise. 0.89. What is the ratio of the Aid flow (current US$) of Malaysia in 1970 to that in 1971?
Offer a very short reply. 0.64. What is the ratio of the Aid flow (current US$) in Tunisia in 1970 to that in 1971?
Give a very brief answer. 0.82. What is the ratio of the Aid flow (current US$) of Upper middle income in 1970 to that in 1972?
Your answer should be very brief. 0.55. What is the ratio of the Aid flow (current US$) of Colombia in 1970 to that in 1972?
Provide a short and direct response. 0.61. What is the ratio of the Aid flow (current US$) of Malaysia in 1970 to that in 1972?
Your answer should be very brief. 0.72. What is the ratio of the Aid flow (current US$) in Tunisia in 1970 to that in 1972?
Your answer should be very brief. 0.37. What is the ratio of the Aid flow (current US$) of Upper middle income in 1970 to that in 1973?
Offer a terse response. 0.56. What is the ratio of the Aid flow (current US$) in Colombia in 1970 to that in 1973?
Provide a short and direct response. 0.72. What is the ratio of the Aid flow (current US$) of Malaysia in 1970 to that in 1973?
Keep it short and to the point. 0.87. What is the ratio of the Aid flow (current US$) in Tunisia in 1970 to that in 1973?
Ensure brevity in your answer.  0.43. What is the ratio of the Aid flow (current US$) in Upper middle income in 1970 to that in 1974?
Give a very brief answer. 0.55. What is the ratio of the Aid flow (current US$) in Colombia in 1970 to that in 1974?
Offer a very short reply. 1.37. What is the ratio of the Aid flow (current US$) of Malaysia in 1970 to that in 1974?
Your response must be concise. 1.35. What is the ratio of the Aid flow (current US$) in Tunisia in 1970 to that in 1974?
Provide a succinct answer. 0.4. What is the ratio of the Aid flow (current US$) of Upper middle income in 1971 to that in 1972?
Offer a very short reply. 0.69. What is the ratio of the Aid flow (current US$) in Colombia in 1971 to that in 1972?
Offer a very short reply. 0.69. What is the ratio of the Aid flow (current US$) of Malaysia in 1971 to that in 1972?
Make the answer very short. 1.13. What is the ratio of the Aid flow (current US$) in Tunisia in 1971 to that in 1972?
Your answer should be very brief. 0.45. What is the ratio of the Aid flow (current US$) in Upper middle income in 1971 to that in 1973?
Provide a short and direct response. 0.7. What is the ratio of the Aid flow (current US$) in Colombia in 1971 to that in 1973?
Provide a short and direct response. 0.81. What is the ratio of the Aid flow (current US$) in Malaysia in 1971 to that in 1973?
Offer a very short reply. 1.36. What is the ratio of the Aid flow (current US$) of Tunisia in 1971 to that in 1973?
Your response must be concise. 0.53. What is the ratio of the Aid flow (current US$) of Upper middle income in 1971 to that in 1974?
Your answer should be very brief. 0.69. What is the ratio of the Aid flow (current US$) in Colombia in 1971 to that in 1974?
Keep it short and to the point. 1.54. What is the ratio of the Aid flow (current US$) of Malaysia in 1971 to that in 1974?
Provide a short and direct response. 2.1. What is the ratio of the Aid flow (current US$) of Tunisia in 1971 to that in 1974?
Offer a very short reply. 0.49. What is the ratio of the Aid flow (current US$) of Upper middle income in 1972 to that in 1973?
Offer a very short reply. 1.01. What is the ratio of the Aid flow (current US$) of Colombia in 1972 to that in 1973?
Provide a succinct answer. 1.18. What is the ratio of the Aid flow (current US$) of Malaysia in 1972 to that in 1973?
Provide a short and direct response. 1.2. What is the ratio of the Aid flow (current US$) of Tunisia in 1972 to that in 1973?
Provide a short and direct response. 1.18. What is the ratio of the Aid flow (current US$) of Colombia in 1972 to that in 1974?
Your response must be concise. 2.23. What is the ratio of the Aid flow (current US$) in Malaysia in 1972 to that in 1974?
Make the answer very short. 1.86. What is the ratio of the Aid flow (current US$) in Tunisia in 1972 to that in 1974?
Keep it short and to the point. 1.1. What is the ratio of the Aid flow (current US$) of Upper middle income in 1973 to that in 1974?
Provide a short and direct response. 0.99. What is the ratio of the Aid flow (current US$) in Colombia in 1973 to that in 1974?
Provide a short and direct response. 1.89. What is the ratio of the Aid flow (current US$) of Malaysia in 1973 to that in 1974?
Keep it short and to the point. 1.54. What is the ratio of the Aid flow (current US$) of Tunisia in 1973 to that in 1974?
Offer a terse response. 0.94. What is the difference between the highest and the second highest Aid flow (current US$) of Upper middle income?
Provide a succinct answer. 2.30e+05. What is the difference between the highest and the second highest Aid flow (current US$) of Colombia?
Provide a short and direct response. 7.70e+05. What is the difference between the highest and the second highest Aid flow (current US$) of Malaysia?
Offer a terse response. 3.80e+05. What is the difference between the highest and the second highest Aid flow (current US$) in Tunisia?
Your answer should be compact. 1.25e+06. What is the difference between the highest and the lowest Aid flow (current US$) of Upper middle income?
Your answer should be very brief. 2.87e+07. What is the difference between the highest and the lowest Aid flow (current US$) in Colombia?
Your answer should be compact. 4.55e+06. What is the difference between the highest and the lowest Aid flow (current US$) of Malaysia?
Your answer should be very brief. 1.84e+06. What is the difference between the highest and the lowest Aid flow (current US$) in Tunisia?
Your response must be concise. 8.60e+06. 